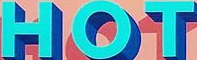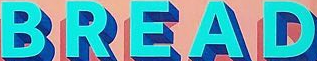What text appears in these images from left to right, separated by a semicolon? HOT; BREAD 